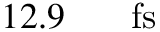<formula> <loc_0><loc_0><loc_500><loc_500>1 2 . 9 { { \, } } { f s }</formula> 